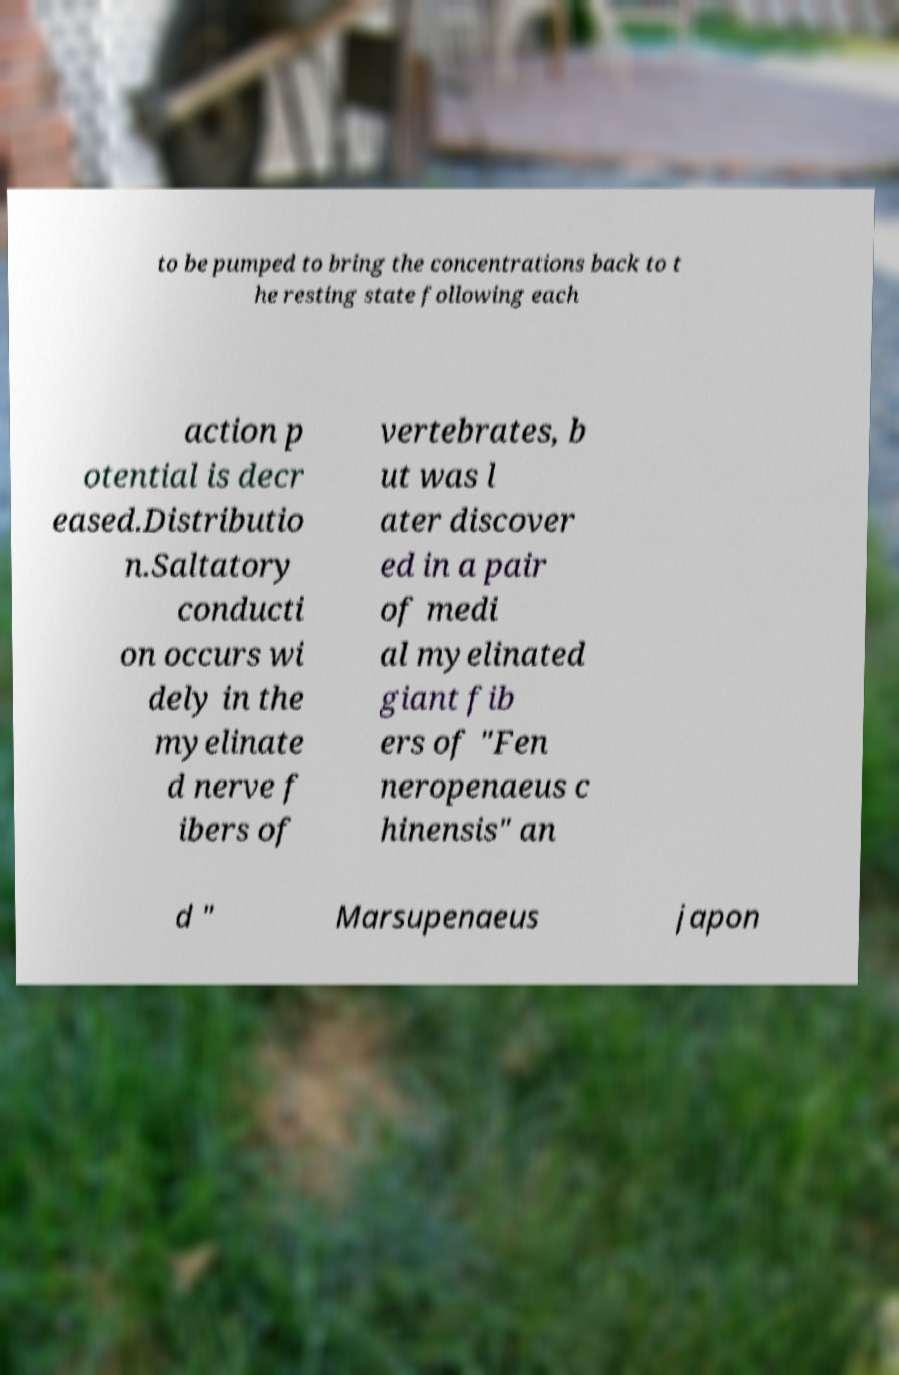I need the written content from this picture converted into text. Can you do that? to be pumped to bring the concentrations back to t he resting state following each action p otential is decr eased.Distributio n.Saltatory conducti on occurs wi dely in the myelinate d nerve f ibers of vertebrates, b ut was l ater discover ed in a pair of medi al myelinated giant fib ers of "Fen neropenaeus c hinensis" an d " Marsupenaeus japon 